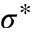Convert formula to latex. <formula><loc_0><loc_0><loc_500><loc_500>\sigma ^ { * }</formula> 